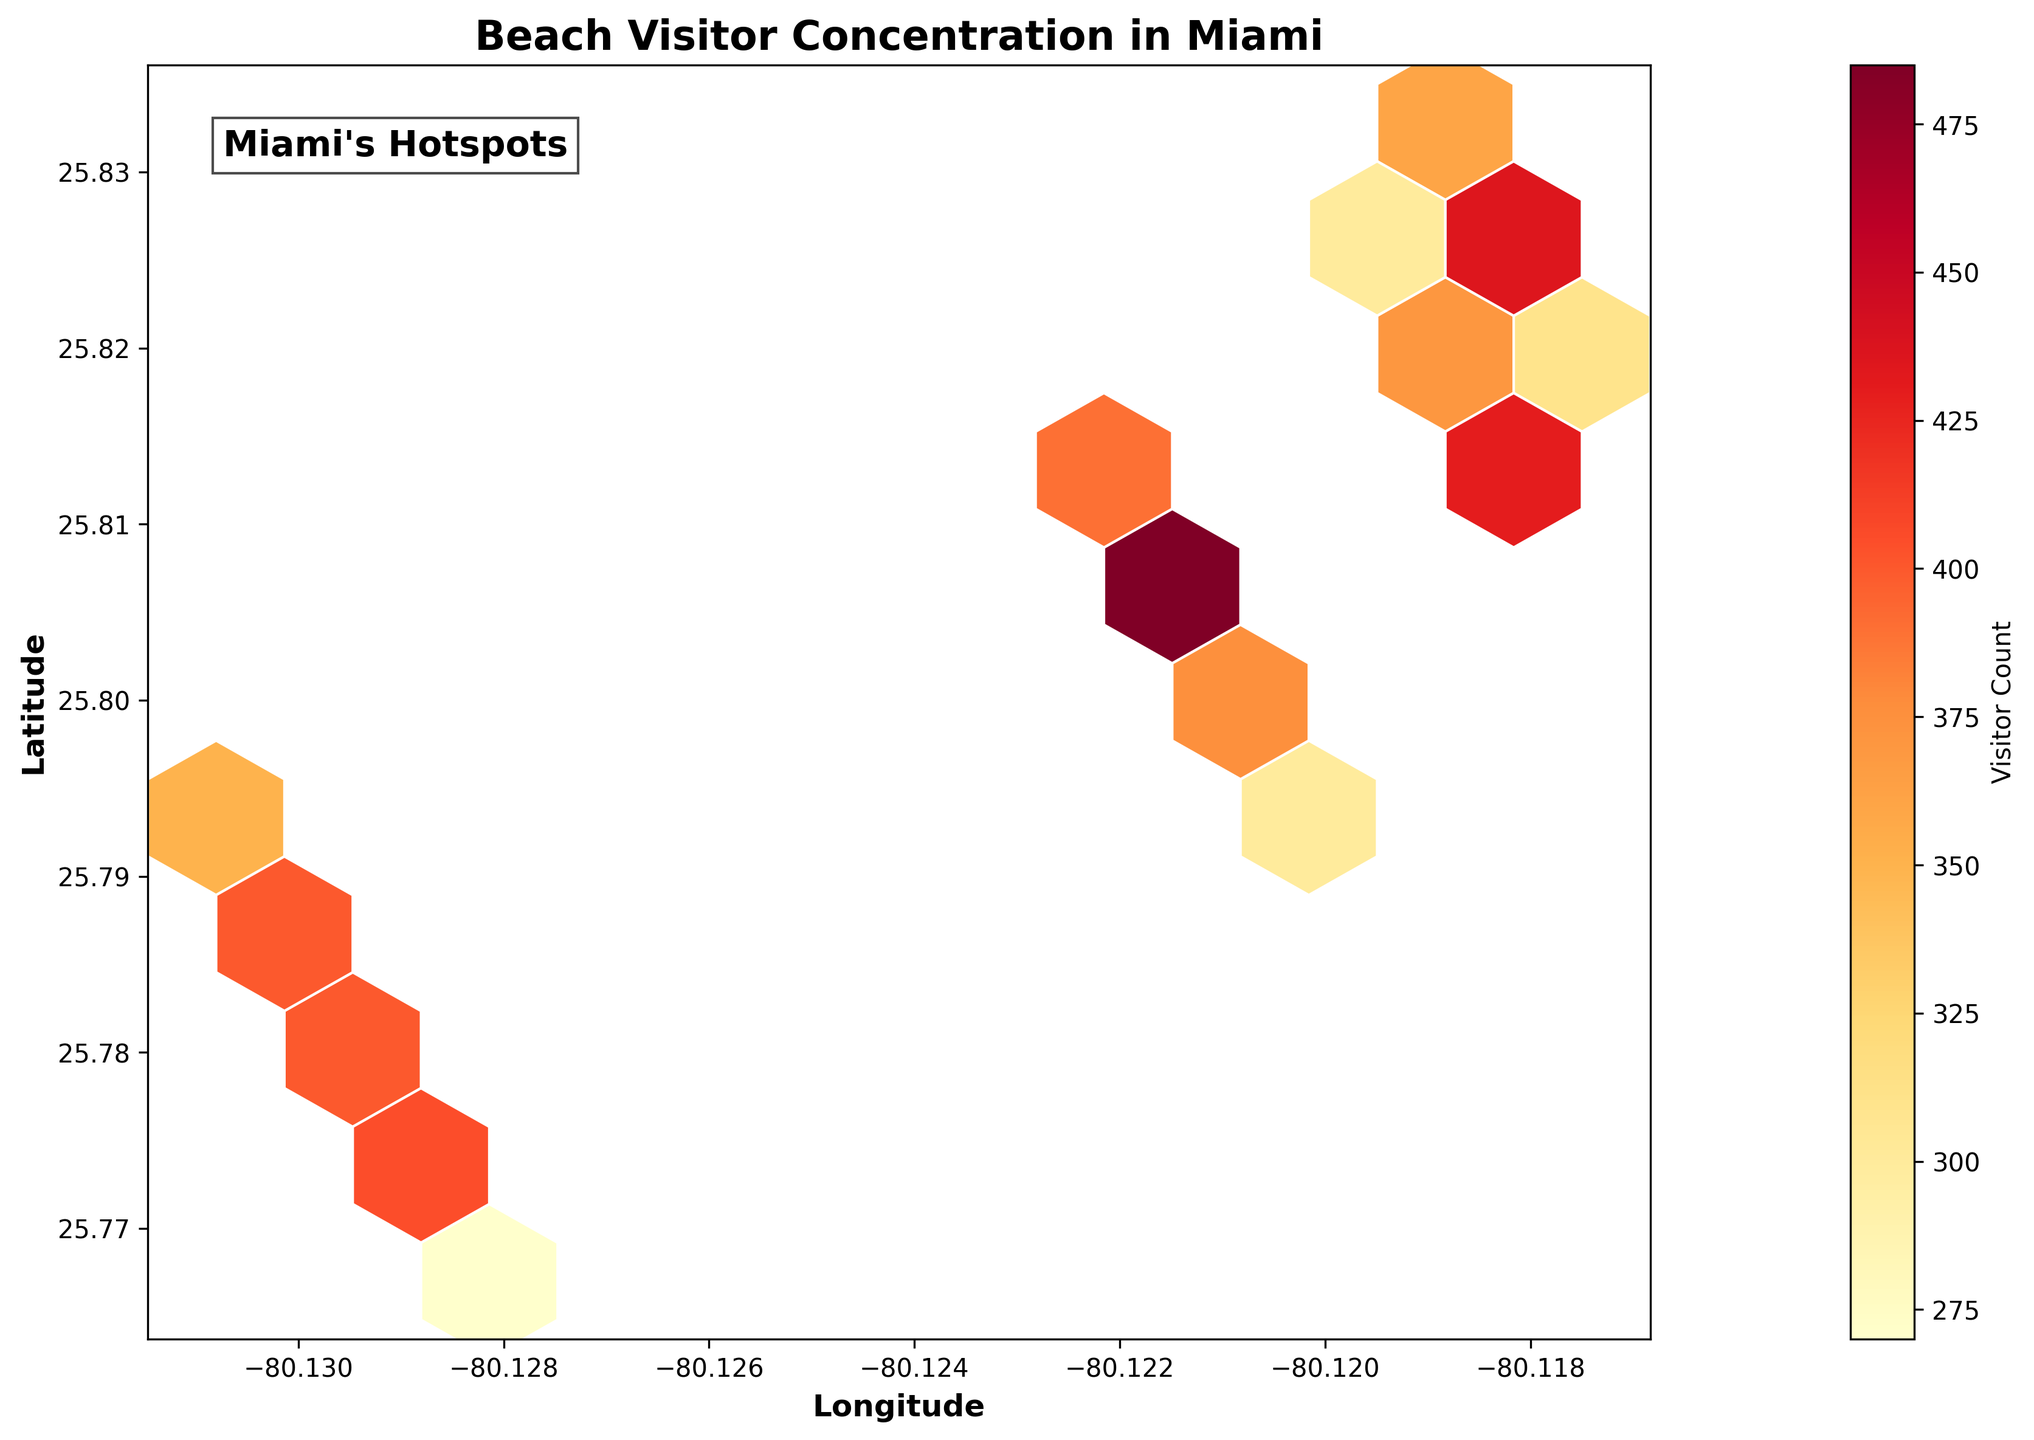What is the title of the figure? The title is positioned at the top of the figure in a larger and bold font. It helps summarize the plot's content in a concise manner.
Answer: Beach Visitor Concentration in Miami What colors are used in the hexagonal bins? The hexagonal bins use a color gradient ranging from lighter yellow to dark red. This gradient indicates varying levels of visitor count, with lighter colors representing lower counts and darker colors representing higher counts.
Answer: Yellow to Red Which axis represents latitude? The y-axis represents latitude. It is labeled clearly with the word "Latitude" in bold font on the left side of the plot.
Answer: Y-axis What does the color bar indicate in the figure? The color bar, positioned to the right of the plot, indicates the range of visitor counts associated with the colors in the hexagonal bins. The label "Visitor Count" is shown next to it.
Answer: Visitor Count Which has more visitors: the darker hexagonal bins or the lighter ones? The darker hexagonal bins represent areas with a higher concentration of visitors, while the lighter bins represent fewer visitors. This can be discerned from the gradient on the color bar.
Answer: Darker bins Where is the highest concentration of visitors along Miami's coastline? The highest concentration of visitors is indicated by the darkest hexagonal bins. These are located around the coordinates latitude 25.8050 and longitude -80.1217 on the plot.
Answer: Around latitude 25.8050 and longitude -80.1217 How do visitor concentrations change as you move horizontally along the longitude axis? Visitor concentrations change from yellow to red and back to yellow as you move horizontally along the longitude axis, indicating varying densities of beachgoers along the coast.
Answer: Varies with peaks and troughs What might you say about regions with coordinates (latitude 25.7742, longitude -80.1292) and (latitude 25.8256, longitude -80.1178) in terms of visitor counts? Both regions have darker colored bins indicating high visitor concentrations. By looking at the plot, these areas are within higher visitor count regions, possibly due to popular beach locations.
Answer: High visitor counts What is the approximate visitor count for the most populated region? By looking at the color bar and the darkest hexagonal bins, the approximate visitor count would be around the highest end of the visitor count range on the bar, close to 520.
Answer: Around 520 What pattern can you observe regarding the distribution of beach visitors along the Miami coastline? The distribution shows clusters of high visitor concentrations, primarily centered around specific latitude and longitude points, with lower densities in between these hotspots.
Answer: Clusters with high visitor density 